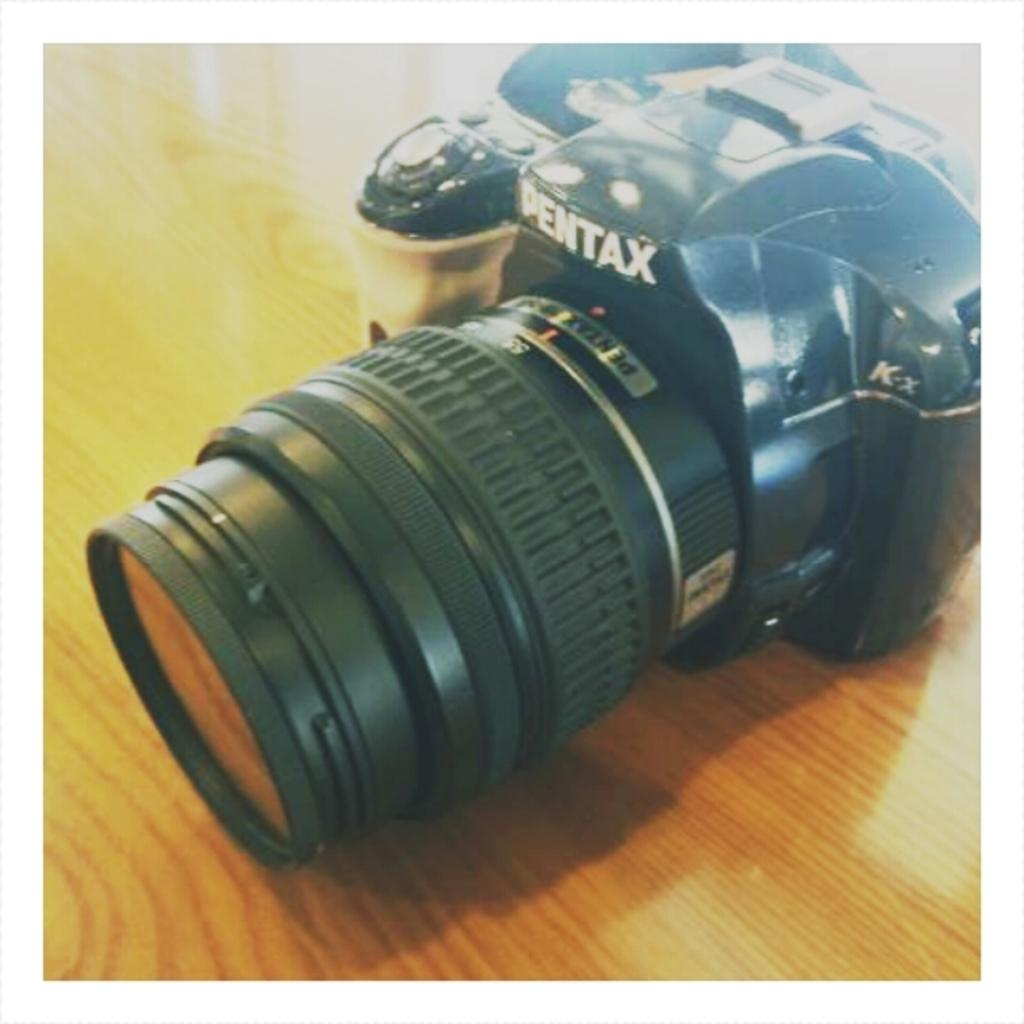What object is the main subject of the image? There is a camera in the image. Where is the camera located? The camera is on a table. What type of battle is taking place in the image? There is no battle present in the image; it features a camera on a table. What type of fan is visible in the image? There is no fan present in the image. 